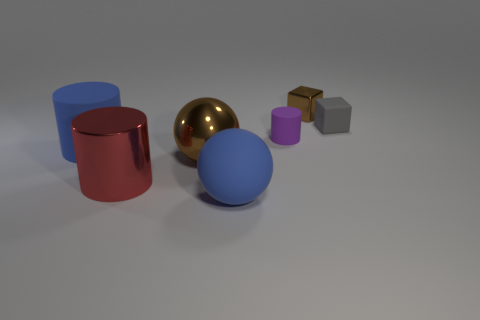Add 2 brown blocks. How many objects exist? 9 Subtract all cubes. How many objects are left? 5 Add 5 large blue cylinders. How many large blue cylinders exist? 6 Subtract 1 blue spheres. How many objects are left? 6 Subtract all brown metal objects. Subtract all large brown spheres. How many objects are left? 4 Add 3 balls. How many balls are left? 5 